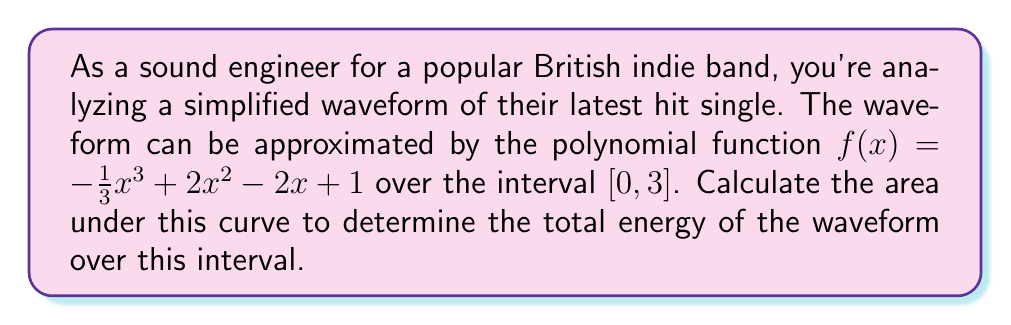Could you help me with this problem? To find the area under the curve, we need to calculate the definite integral of the function $f(x)$ from 0 to 3.

1) The integral of $f(x) = -\frac{1}{3}x^3 + 2x^2 - 2x + 1$ is:

   $F(x) = -\frac{1}{12}x^4 + \frac{2}{3}x^3 - x^2 + x + C$

2) Now, we need to evaluate $F(3) - F(0)$:

   $F(3) = -\frac{1}{12}(3^4) + \frac{2}{3}(3^3) - 3^2 + 3$
         $= -\frac{81}{12} + 18 - 9 + 3$
         $= -\frac{81}{12} + 12$
         $= \frac{63}{12} = \frac{21}{4}$

   $F(0) = 0$

3) Therefore, the area under the curve is:

   $F(3) - F(0) = \frac{21}{4} - 0 = \frac{21}{4}$

This represents the total energy of the waveform over the given interval.
Answer: $\frac{21}{4}$ or 5.25 units squared 